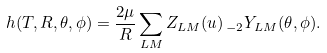Convert formula to latex. <formula><loc_0><loc_0><loc_500><loc_500>h ( T , R , \theta , \phi ) = \frac { 2 \mu } { R } \sum _ { L M } Z _ { L M } ( u ) \, _ { - 2 } Y _ { L M } ( \theta , \phi ) .</formula> 